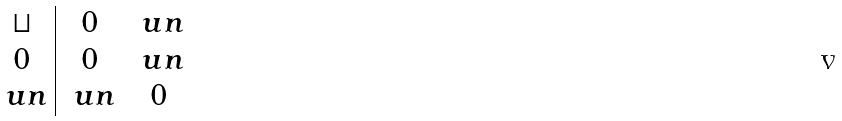Convert formula to latex. <formula><loc_0><loc_0><loc_500><loc_500>\begin{array} { c | c c } \sqcup & 0 & \ u n \\ 0 & 0 & \ u n \\ \ u n & \ u n & 0 \end{array}</formula> 